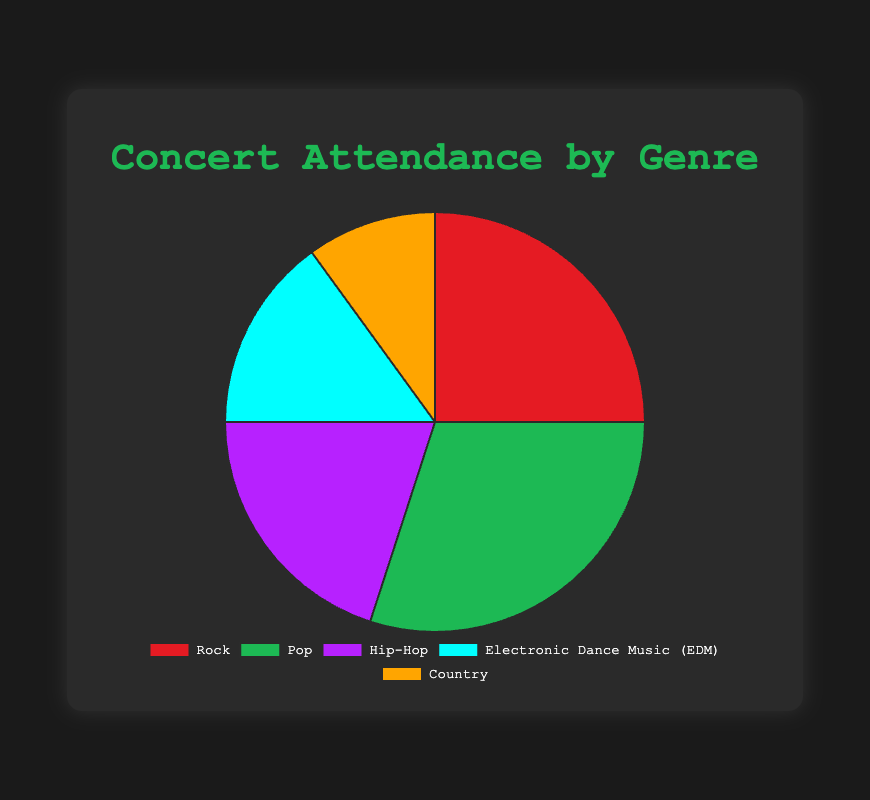What percentage of concert attendance is attributed to Pop music? Pop music accounts for 30% of the total concert attendance. This can be seen directly on the pie chart where the Pop segment is labeled with its percentage.
Answer: 30% Which genre has the highest concert attendance, and which has the lowest? The genre with the highest concert attendance is Pop with 30%, and the genre with the lowest is Country with 10%. This is indicated by the size of the segments in the pie chart, with Pop having the largest and Country the smallest.
Answer: Pop; Country How much more popular is Rock compared to Country in terms of concert attendance? To determine how much more popular Rock is compared to Country, subtract Country's attendance percentage (10%) from Rock's attendance percentage (25%). 25% - 10% = 15%.
Answer: 15% What is the combined concert attendance percentage for Rock and Hip-Hop? Add the percentages for Rock (25%) and Hip-Hop (20%). 25% + 20% = 45%.
Answer: 45% What proportion of concert attendance is for genres other than Pop? Subtract the percentage of Pop (30%) from 100%. This gives the combined attendance percentage for all other genres. 100% - 30% = 70%.
Answer: 70% Compare the attendance of Electronic Dance Music (EDM) and Hip-Hop. Which one is more attended and by how much? Hip-Hop (20%) has a higher concert attendance compared to EDM (15%). To find out by how much, subtract EDM's percentage from Hip-Hop's percentage: 20% - 15% = 5%.
Answer: Hip-Hop; 5% How does the concert attendance for Rock compare to Electronic Dance Music (EDM) and Country combined? First, add the attendance percentages for EDM (15%) and Country (10%): 15% + 10% = 25%. Then compare it to Rock's attendance which is also 25%. Both are equal.
Answer: Rock is equal to EDM + Country What is the average concert attendance percentage for Hip-Hop and Country? Add the percentages for Hip-Hop (20%) and Country (10%) and then divide by 2 to find the average. (20% + 10%) / 2 = 15%.
Answer: 15% Which genre is represented by the green segment in the pie chart, and what percentage does it have? The green segment in the pie chart represents Pop, and it has a percentage of 30%.
Answer: Pop; 30% If a person attended 10 concerts last year, how many were likely for Rock music based on the percentages? To estimate the number of concerts attended for Rock music out of 10, multiply 10 by the percentage for Rock (25%). 10 * 25% = 2.5. Since a person can't attend half a concert, it likely rounds to 2 or 3 concerts.
Answer: 2-3 concerts 